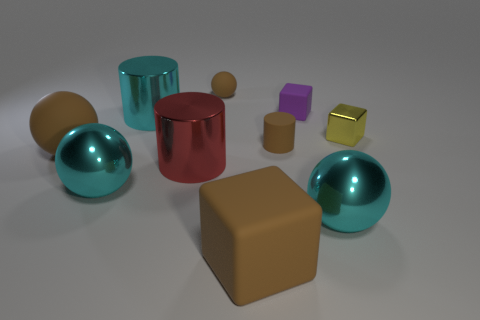Subtract all brown balls. How many were subtracted if there are1brown balls left? 1 Subtract all tiny spheres. How many spheres are left? 3 Subtract 1 balls. How many balls are left? 3 Subtract all spheres. How many objects are left? 6 Subtract all gray cylinders. Subtract all gray cubes. How many cylinders are left? 3 Subtract all yellow balls. How many brown blocks are left? 1 Subtract all large balls. Subtract all big brown rubber cubes. How many objects are left? 6 Add 8 big brown things. How many big brown things are left? 10 Add 3 tiny brown matte cylinders. How many tiny brown matte cylinders exist? 4 Subtract all brown spheres. How many spheres are left? 2 